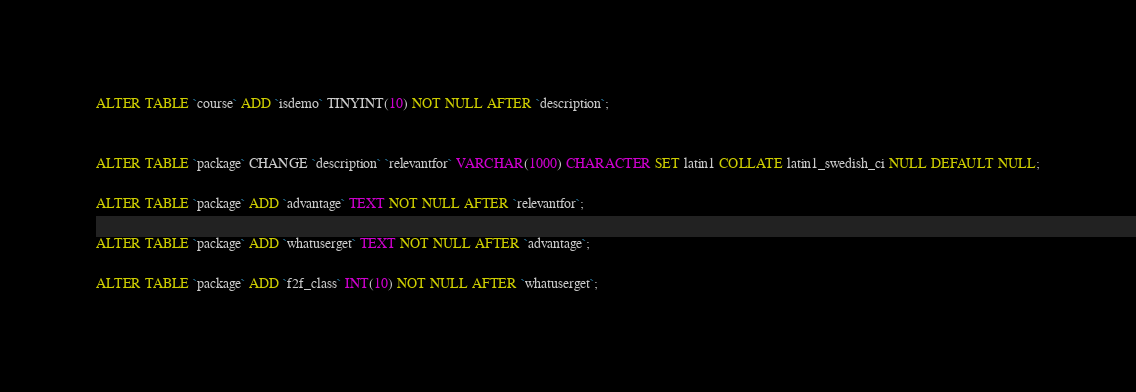<code> <loc_0><loc_0><loc_500><loc_500><_SQL_>ALTER TABLE `course` ADD `isdemo` TINYINT(10) NOT NULL AFTER `description`;


ALTER TABLE `package` CHANGE `description` `relevantfor` VARCHAR(1000) CHARACTER SET latin1 COLLATE latin1_swedish_ci NULL DEFAULT NULL;

ALTER TABLE `package` ADD `advantage` TEXT NOT NULL AFTER `relevantfor`;

ALTER TABLE `package` ADD `whatuserget` TEXT NOT NULL AFTER `advantage`;

ALTER TABLE `package` ADD `f2f_class` INT(10) NOT NULL AFTER `whatuserget`;</code> 